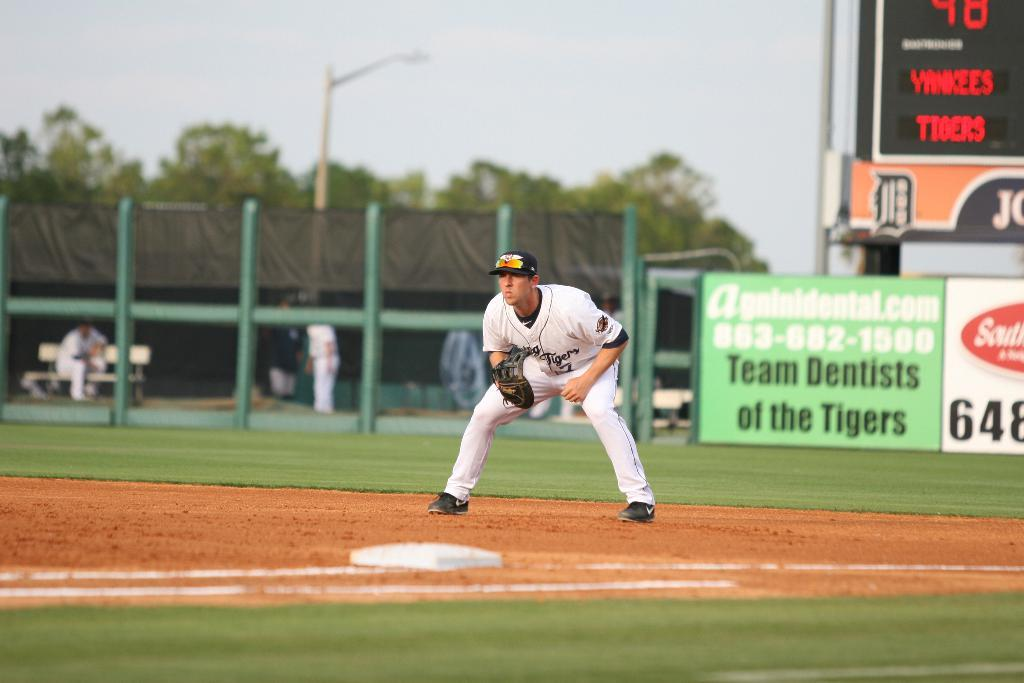<image>
Relay a brief, clear account of the picture shown. A baseball player in front of an ad that says Team Dentists of the Tigers. 